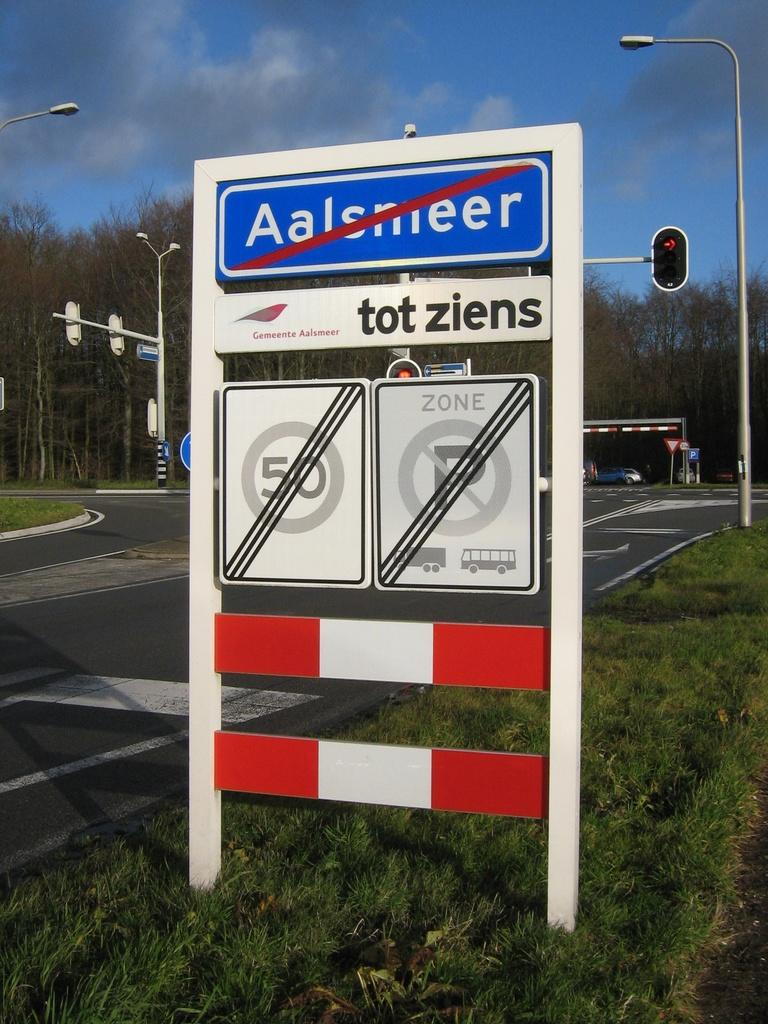<image>
Provide a brief description of the given image. a sign that has the word tot ziens on it 